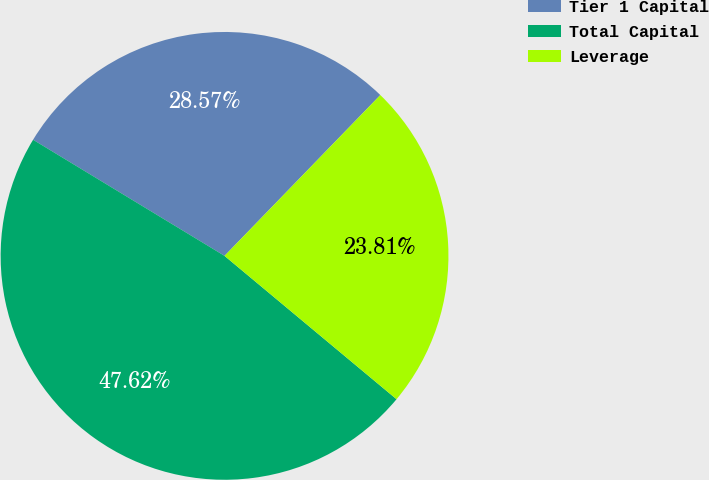<chart> <loc_0><loc_0><loc_500><loc_500><pie_chart><fcel>Tier 1 Capital<fcel>Total Capital<fcel>Leverage<nl><fcel>28.57%<fcel>47.62%<fcel>23.81%<nl></chart> 